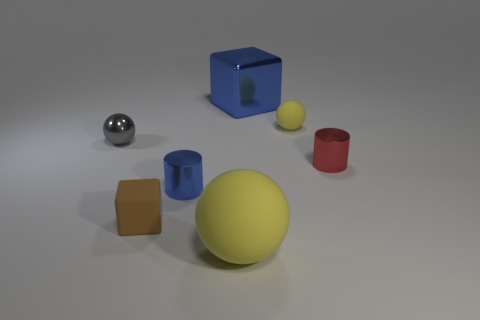What number of other objects are the same shape as the small yellow object? There are two objects that share the same spherical shape as the small yellow ball. These are the large silver ball centrally placed towards the front and the blue ball partially hidden behind the red cylinder on the right. 